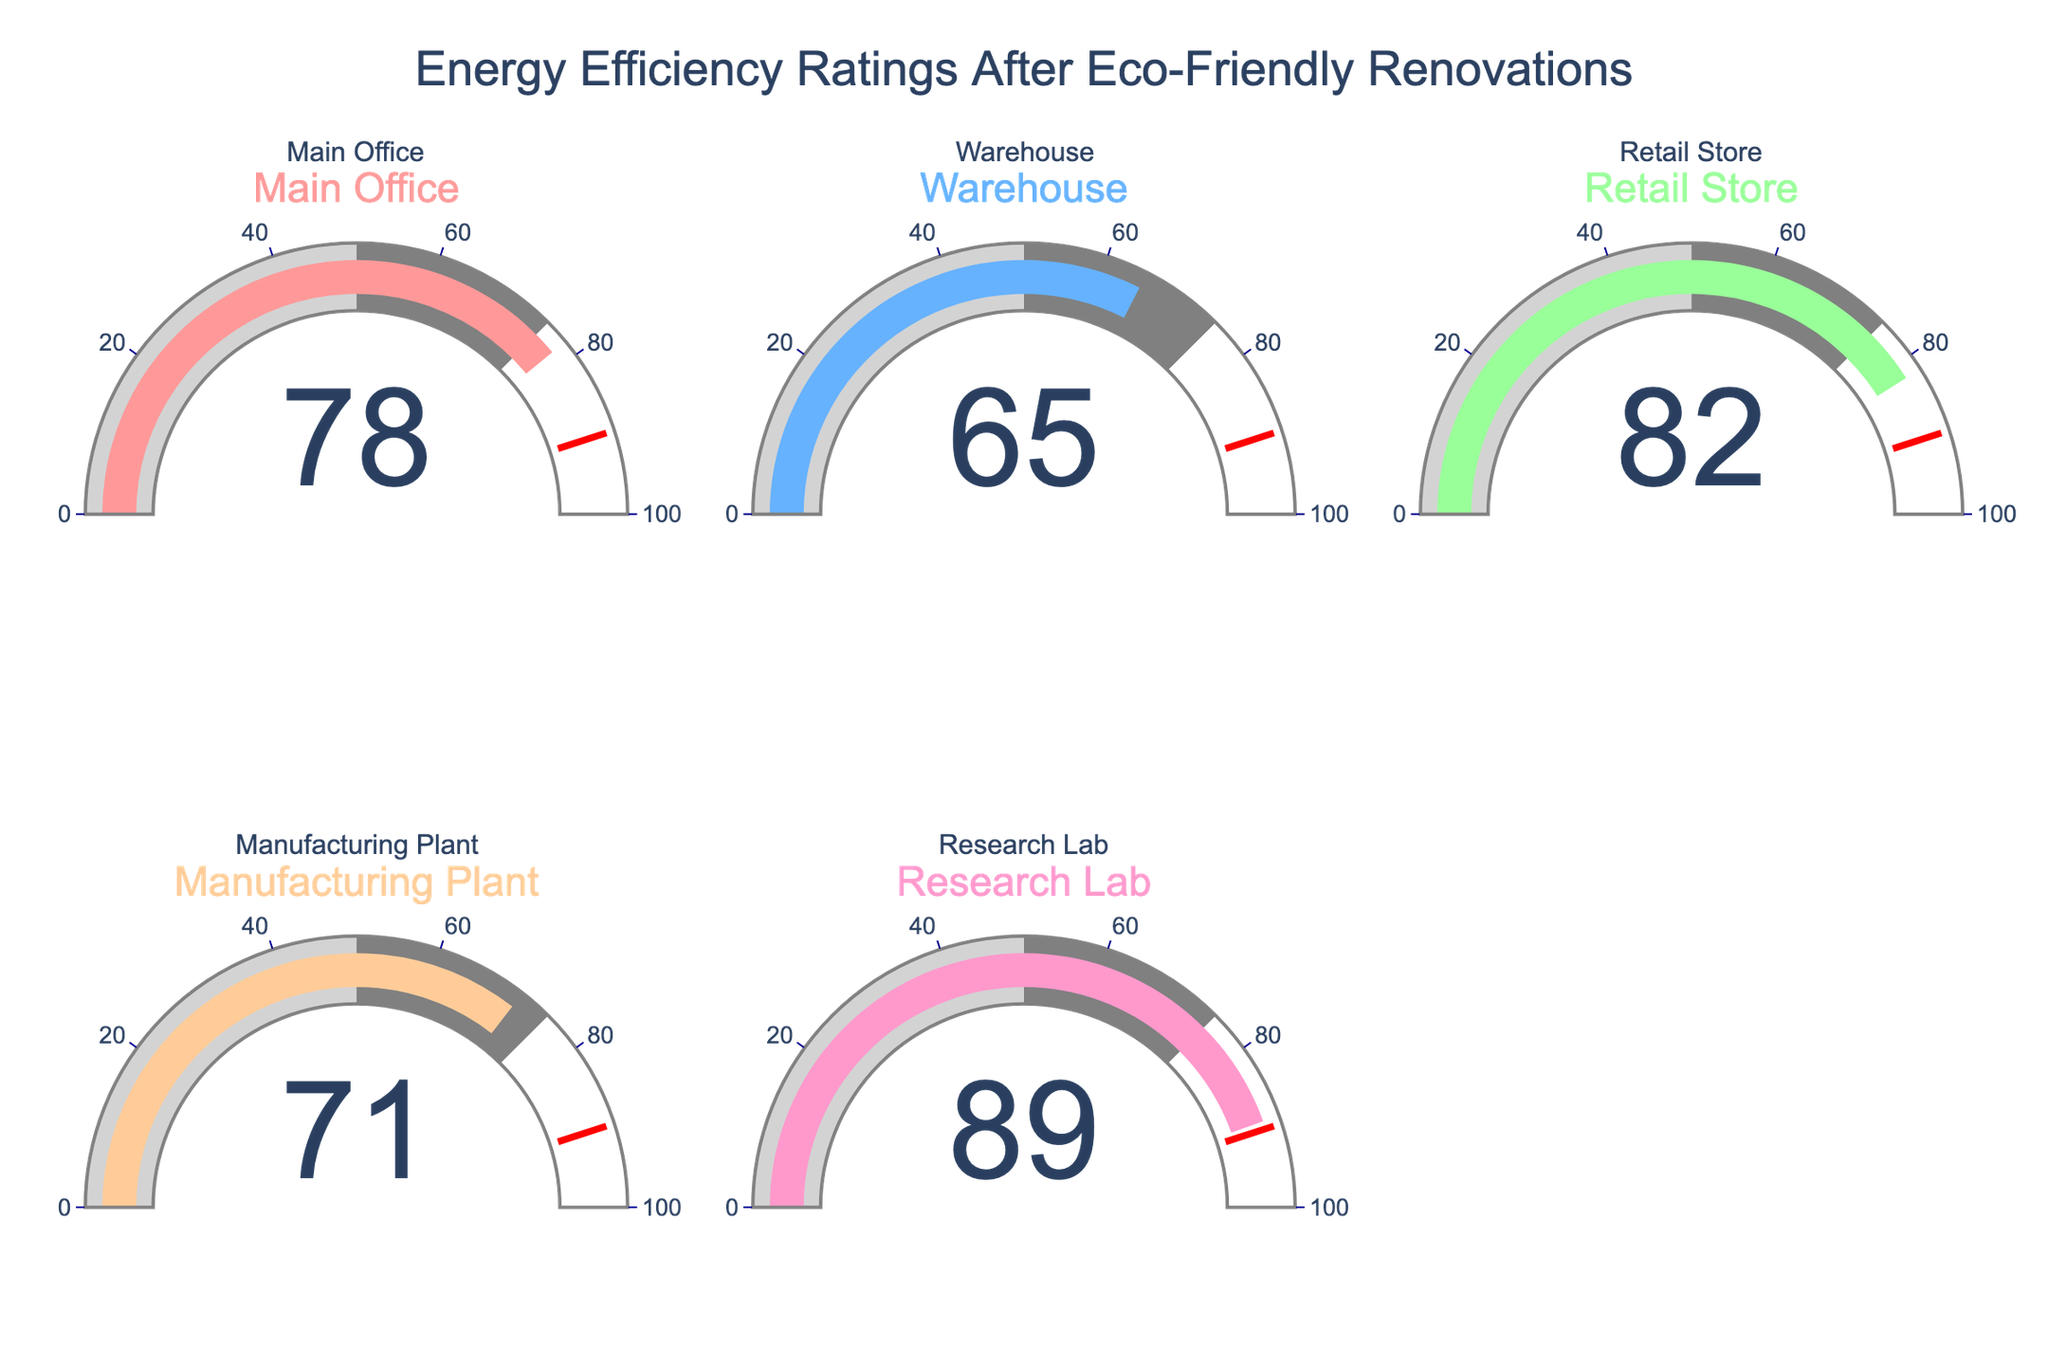What is the energy efficiency rating of the Main Office? Look at the gauge chart for the Main Office and read the number displayed.
Answer: 78 What is the highest energy efficiency rating among the buildings? Compare the numbers displayed on all the gauge charts to find the highest one. The highest number is 89.
Answer: 89 Is the energy efficiency rating of the Manufacturing Plant greater than that of the Warehouse? Compare the numbers on the gauge charts for the Manufacturing Plant and Warehouse. The Manufacturing Plant has a rating of 71, and the Warehouse has a rating of 65. Since 71 > 65, the answer is yes.
Answer: Yes What is the average energy efficiency rating of the Retail Store and Research Lab? Add the ratings of the Retail Store and Research Lab, then divide by 2. That is (82 + 89) / 2 = 85.5.
Answer: 85.5 Which building has the lowest energy efficiency rating? Compare the numbers on all the gauge charts and find the lowest value. The lowest number is 65, which is for the Warehouse.
Answer: Warehouse What is the difference in energy efficiency ratings between the Retail Store and the Main Office? Subtract the Main Office's rating from the Retail Store's rating. That is 82 - 78 = 4.
Answer: 4 How many buildings have an energy efficiency rating above 75? Count the gauge charts with numbers greater than 75. The Main Office, Retail Store, and Research Lab have ratings above 75, totaling 3 buildings.
Answer: 3 If the threshold for excellent energy efficiency is 85, which buildings meet this criterion? Identify gauge charts with numbers equal to or greater than 85. The Research Lab has a rating of 89 which meets the criterion.
Answer: Research Lab 